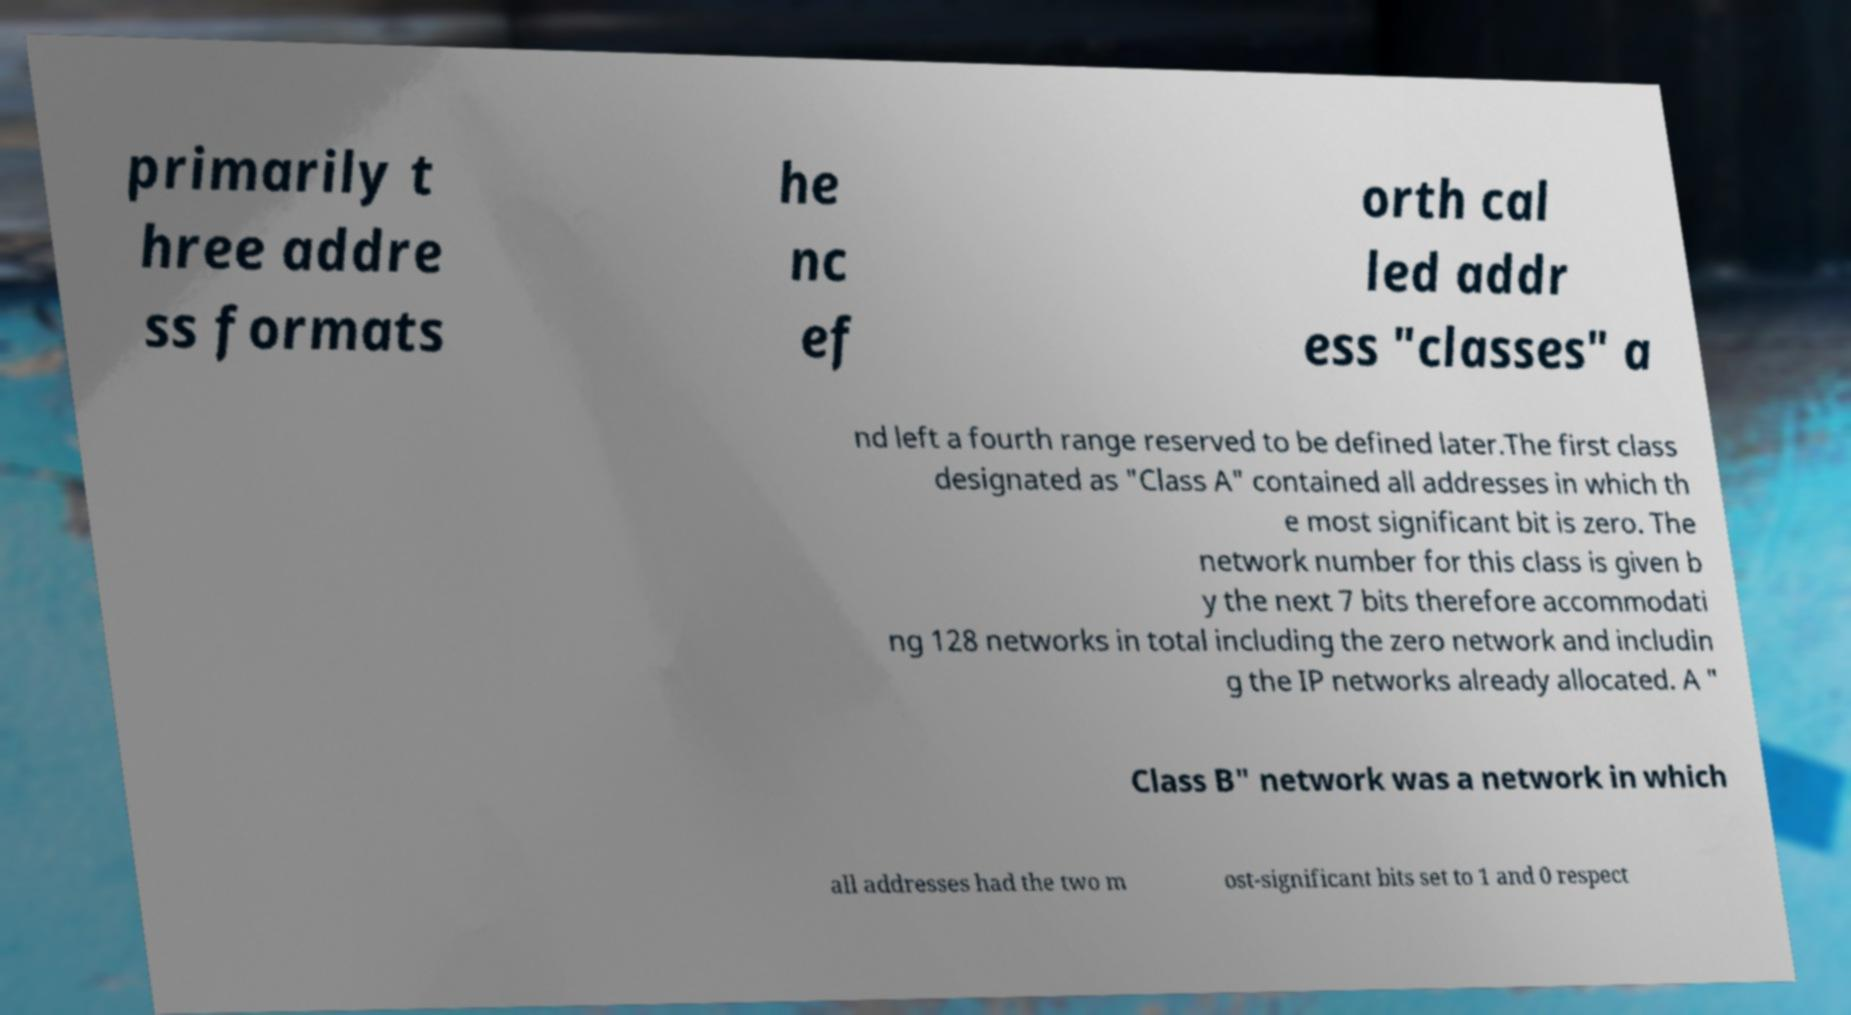Can you read and provide the text displayed in the image?This photo seems to have some interesting text. Can you extract and type it out for me? primarily t hree addre ss formats he nc ef orth cal led addr ess "classes" a nd left a fourth range reserved to be defined later.The first class designated as "Class A" contained all addresses in which th e most significant bit is zero. The network number for this class is given b y the next 7 bits therefore accommodati ng 128 networks in total including the zero network and includin g the IP networks already allocated. A " Class B" network was a network in which all addresses had the two m ost-significant bits set to 1 and 0 respect 